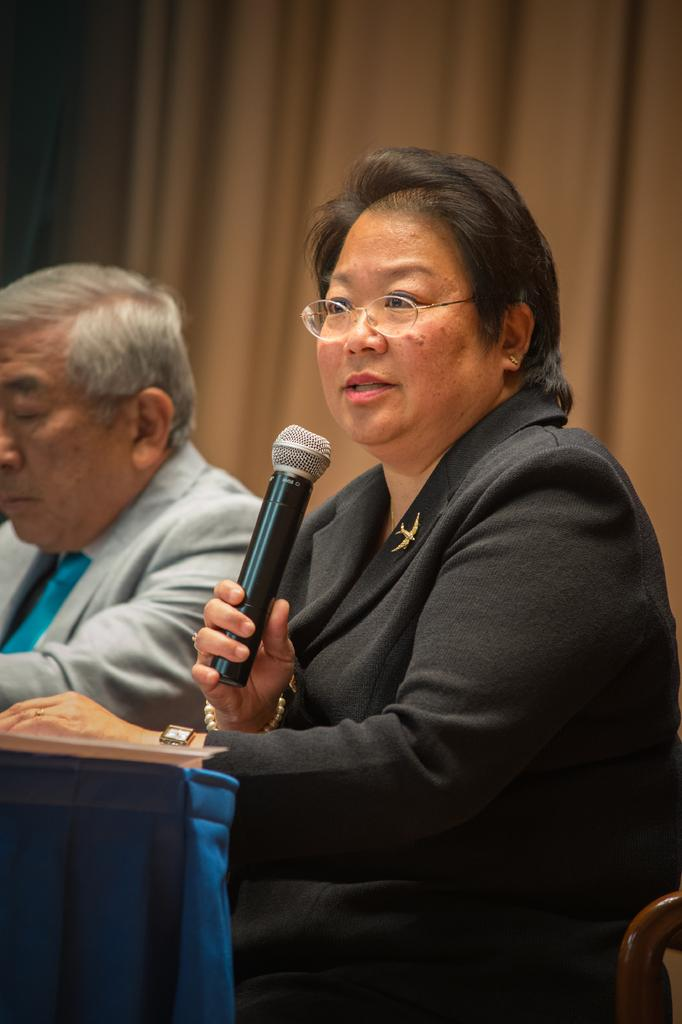What is the position of the person in the image? There is a person sitting on a chair at a table in the image. Can you describe the other person in the image? There is another person on the table in the image. What can be seen in the background of the image? There is a curtain in the background of the image. What type of gold object is being used by the person on the table? There is no gold object present in the image. How does the bomb affect the scene in the image? There is no bomb present in the image. 